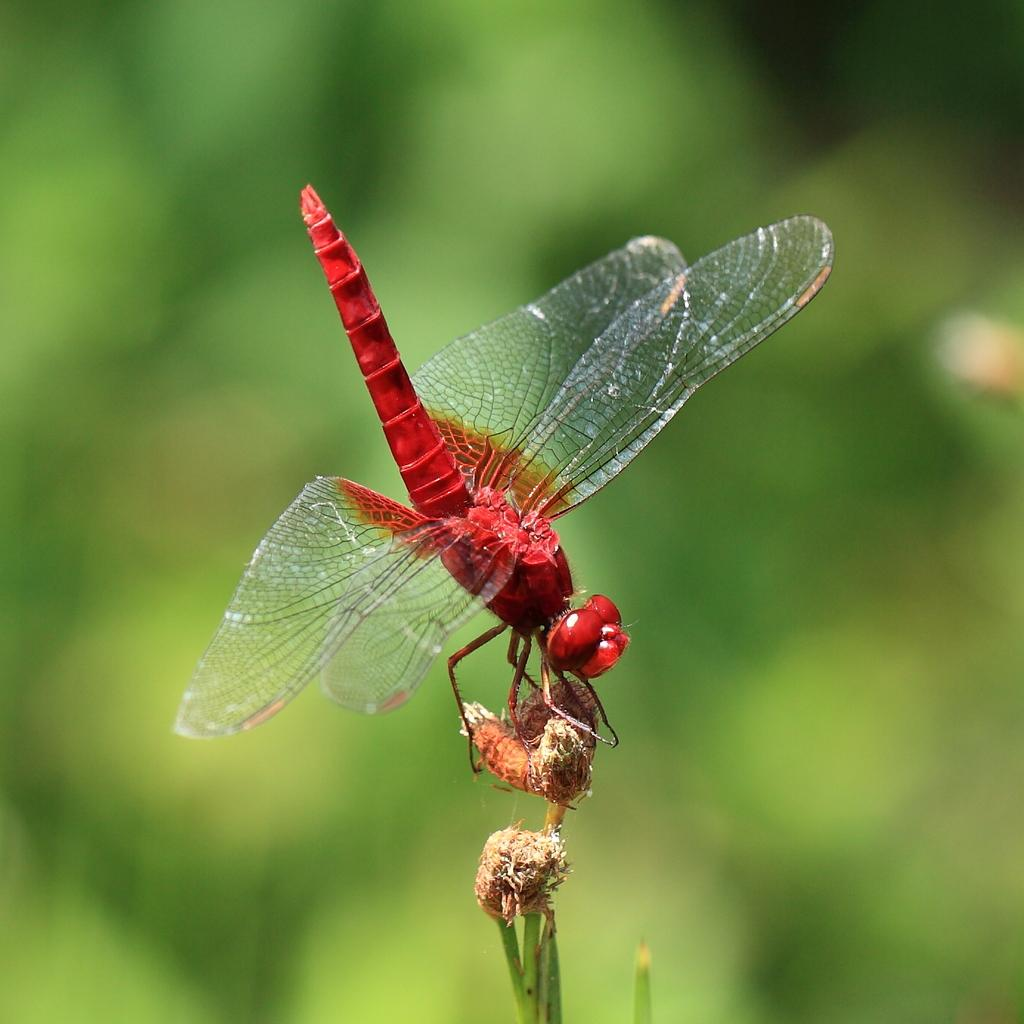What is the main subject of the image? There is a grasshopper in the image. What is the grasshopper holding in the image? The grasshopper is holding a bud. What type of vegetation is visible in the image? There is grass visible in the image. What is the grasshopper's reaction to the degree of heat in the image? There is no information about the temperature or heat in the image, and the grasshopper's reaction cannot be determined. 